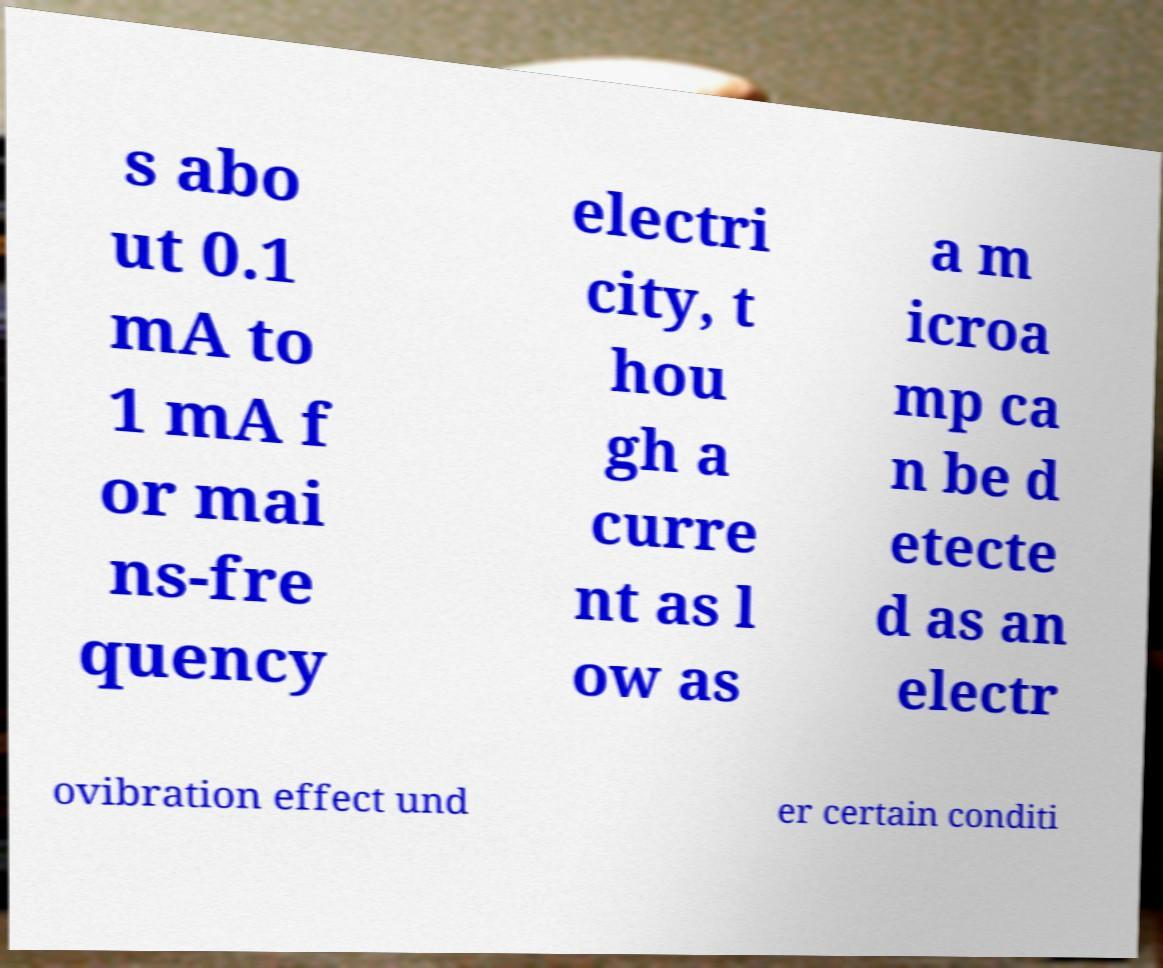Please read and relay the text visible in this image. What does it say? s abo ut 0.1 mA to 1 mA f or mai ns-fre quency electri city, t hou gh a curre nt as l ow as a m icroa mp ca n be d etecte d as an electr ovibration effect und er certain conditi 